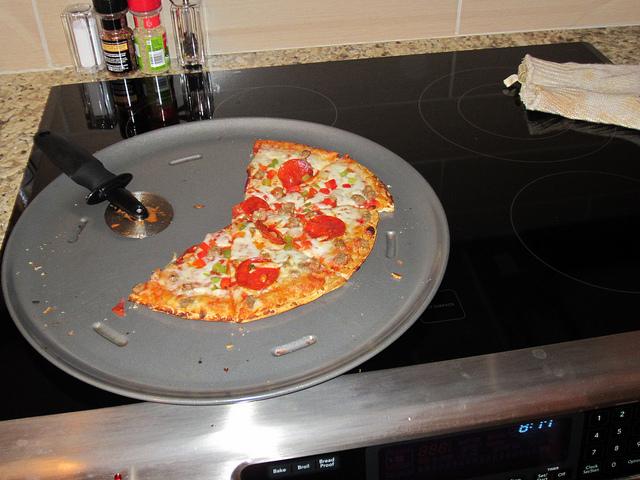What is this room?
Write a very short answer. Kitchen. Are these edible objects high in sugar?
Concise answer only. No. What is the silver object on the counter?
Write a very short answer. Pan. How many slices are left?
Write a very short answer. 5. How many slices of pizza are on the pan?
Short answer required. 5. Is there a pizza cutter on the plate?
Be succinct. Yes. Would a vegetarian eat this?
Be succinct. No. Where are the pizza?
Be succinct. Kitchen. How many burners are on the stove?
Short answer required. 4. What is under the pizza?
Short answer required. Pan. Is the entire pizza on the plate?
Be succinct. No. 